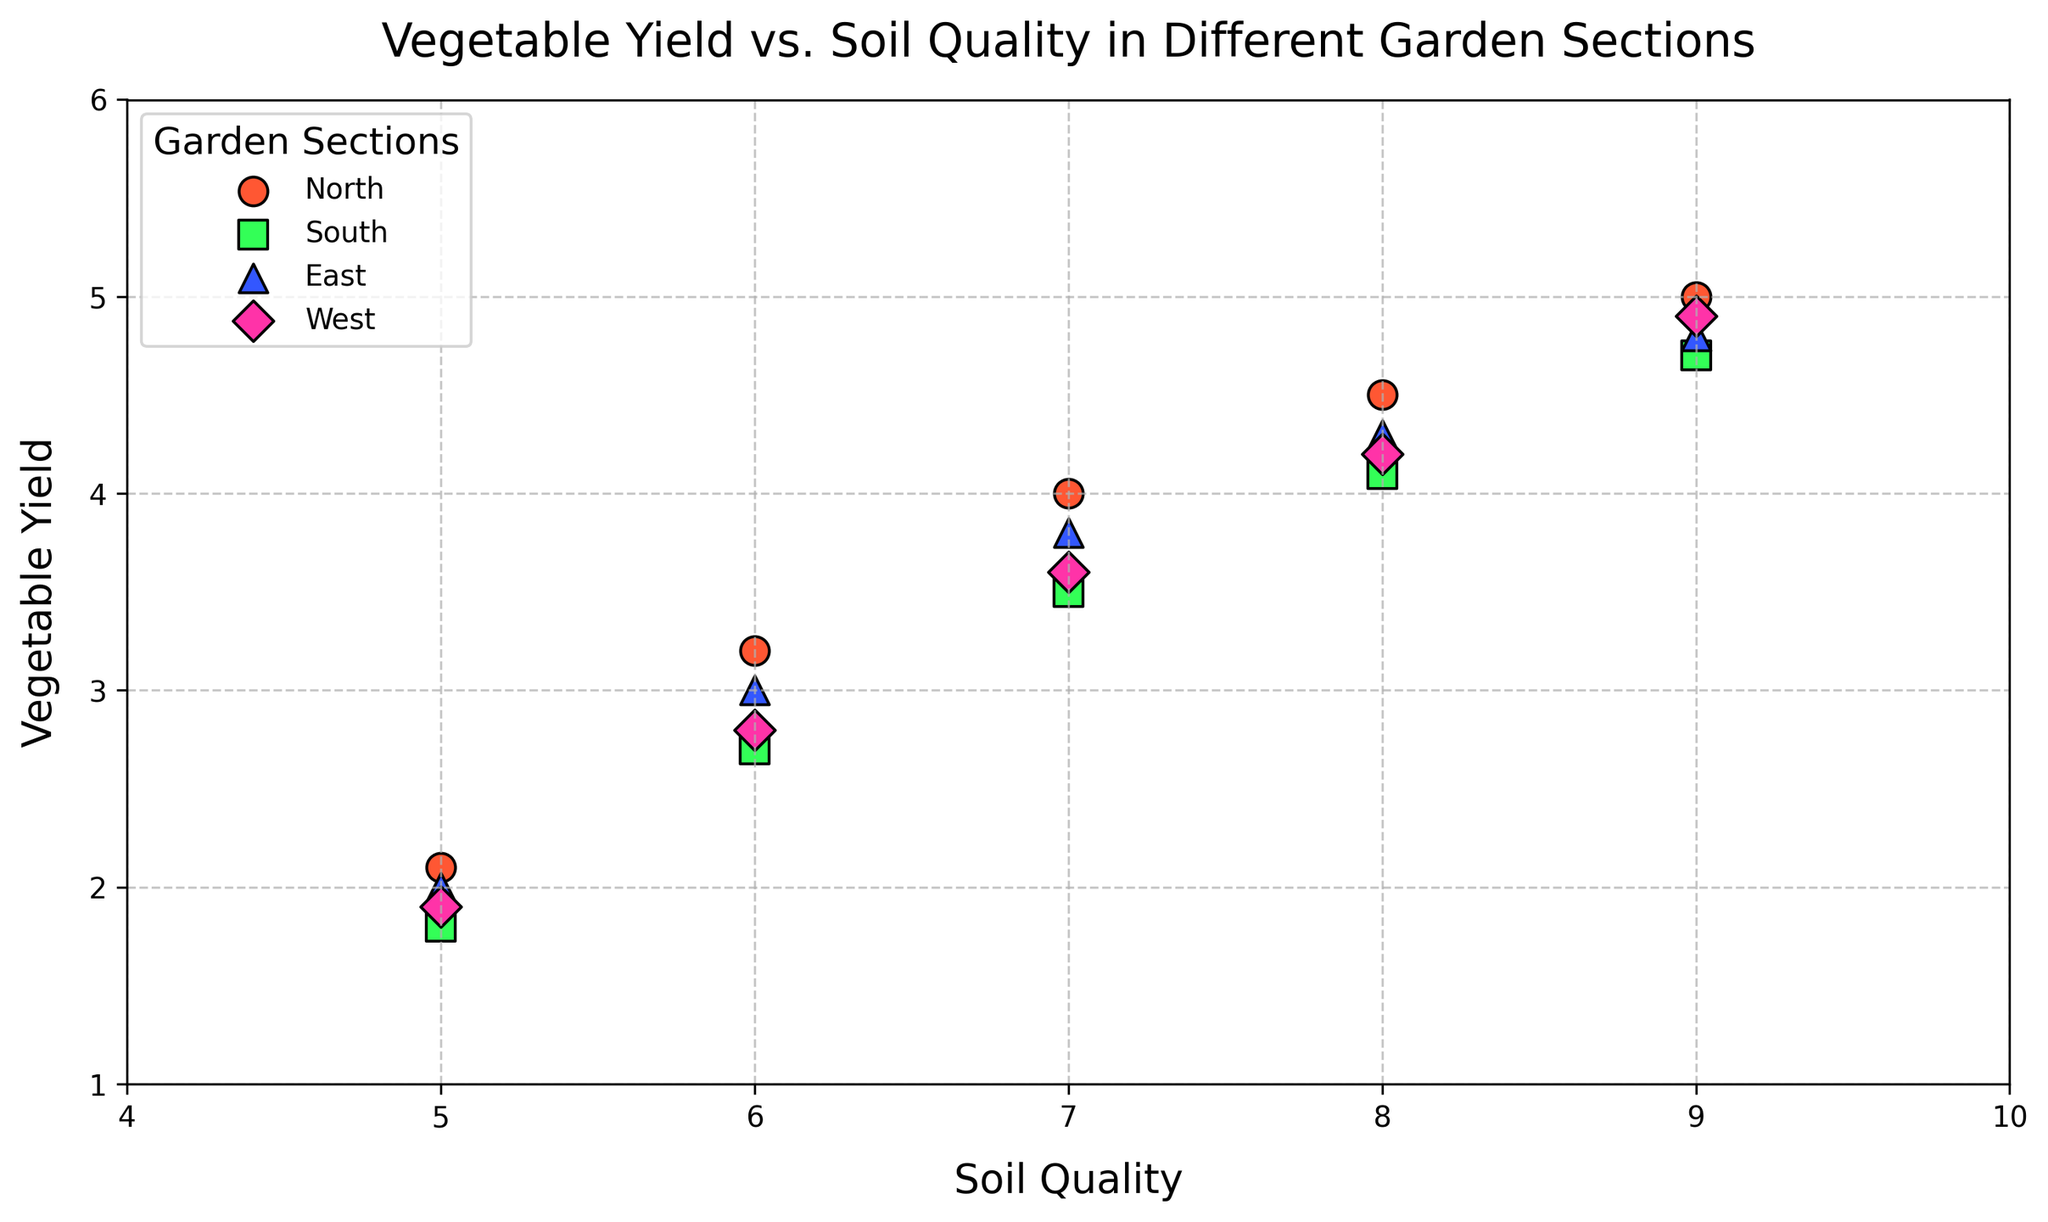What is the relationship between soil quality and vegetable yield for the North section? Look at the data points for the North section; as soil quality increases, vegetable yield also increases.
Answer: Direct relationship Which garden section has the highest vegetable yield for a soil quality of 7? Look at the points where soil quality is 7; compare the vegetable yields. The East section has the highest yield at 3.8.
Answer: East Between the South and West sections, which has a higher vegetable yield for a soil quality of 6? Identify the points for soil quality of 6 for both sections and compare their vegetable yields; South is 2.7 and West is 2.8.
Answer: West How does the vegetable yield increase per unit of soil quality in the East section? Observe the slope of the points in the East section graph. Yield progressively increases by approximately 0.7 per unit of soil quality for values 5 to 9.
Answer: 0.7 per unit What is the average vegetable yield for the North section? Sum the vegetable yields for the North section and divide by the number of data points: (2.1+3.2+4.0+4.5+5.0)/5 = 18.8/5 = 3.76.
Answer: 3.76 Compare the soil quality needed to reach a vegetable yield of 4 in the North and South sections. Which one needs higher soil quality? For the North section, a yield of 4 corresponds to a soil quality of 7. For the South section, a yield of 4 corresponds to a soil quality of 8.
Answer: South What soil quality corresponds to the lowest vegetable yield in the West section? Identify the lowest vegetable yield in the West section, which is 1.9, and its corresponding soil quality, which is 5.
Answer: 5 Which garden section shows the steepest increase in vegetable yield with increasing soil quality? Observe and compare the slopes of the plots for all sections; the North section shows the steepest increase.
Answer: North For a soil quality of 8, which section has the lowest vegetable yield? Identify the points where soil quality is 8 and compare the yields; South section has the lowest yield at 4.1.
Answer: South Is there any section that shows a decrease in vegetable yield with increasing soil quality? Examine all garden sections, no section shows a decrease; all show an increase or stability with increasing soil quality.
Answer: No 